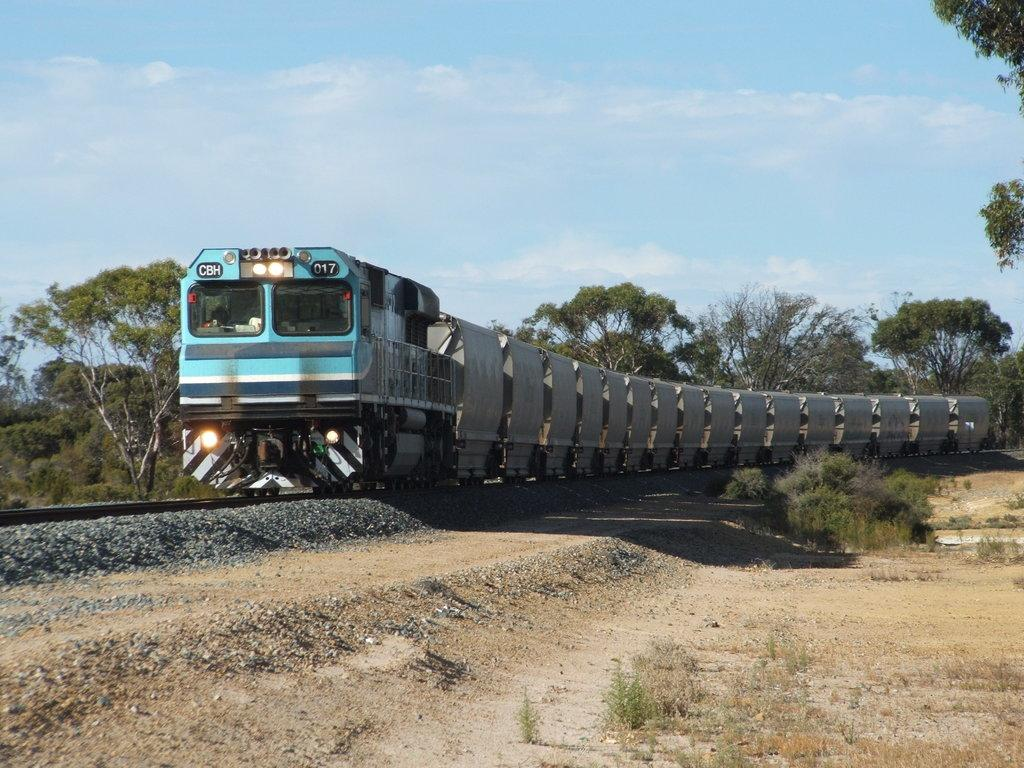What is the main subject of the image? The main subject of the image is a blue train. What is the train doing in the image? The train is running on a track. What can be seen beneath the train in the image? There is a ground visible in the image. What is visible in the background of the image? There are trees visible in the background of the image. What type of bean is being processed in the image? There is no bean or process visible in the image; it features a blue train running on a track. 